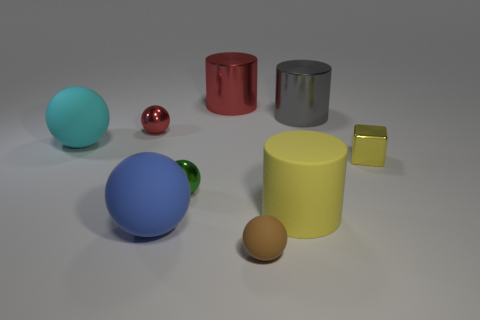What is the brown sphere made of?
Give a very brief answer. Rubber. The big object that is the same color as the small block is what shape?
Keep it short and to the point. Cylinder. What number of gray things are the same size as the brown sphere?
Your answer should be very brief. 0. What number of things are matte things behind the small matte sphere or metallic things that are behind the tiny red metallic ball?
Make the answer very short. 5. Does the tiny object left of the big blue thing have the same material as the small green object that is in front of the large cyan matte thing?
Ensure brevity in your answer.  Yes. What is the shape of the matte thing that is right of the rubber ball that is to the right of the blue matte object?
Your answer should be very brief. Cylinder. Is there any other thing that has the same color as the cube?
Make the answer very short. Yes. Are there any small objects to the left of the big metallic thing that is in front of the large metallic cylinder left of the large yellow cylinder?
Give a very brief answer. Yes. There is a big metallic thing behind the big gray metallic object; is its color the same as the small thing that is left of the big blue ball?
Keep it short and to the point. Yes. There is a brown sphere that is the same size as the red sphere; what material is it?
Keep it short and to the point. Rubber. 